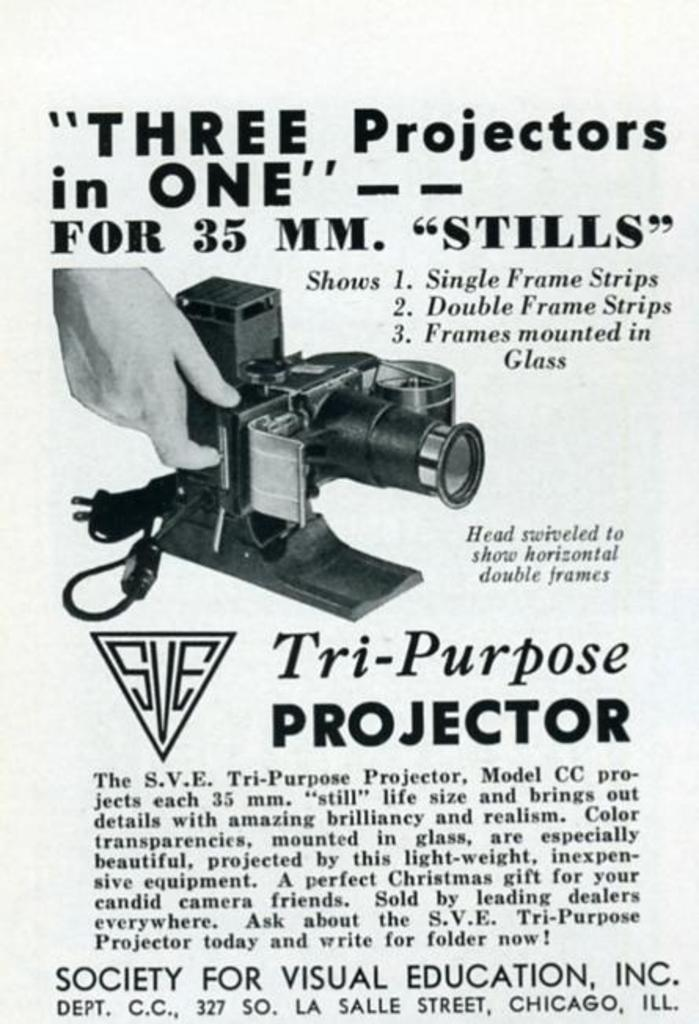<image>
Create a compact narrative representing the image presented. The Tri-Purpose Projector is marketed as three projectors in one. 